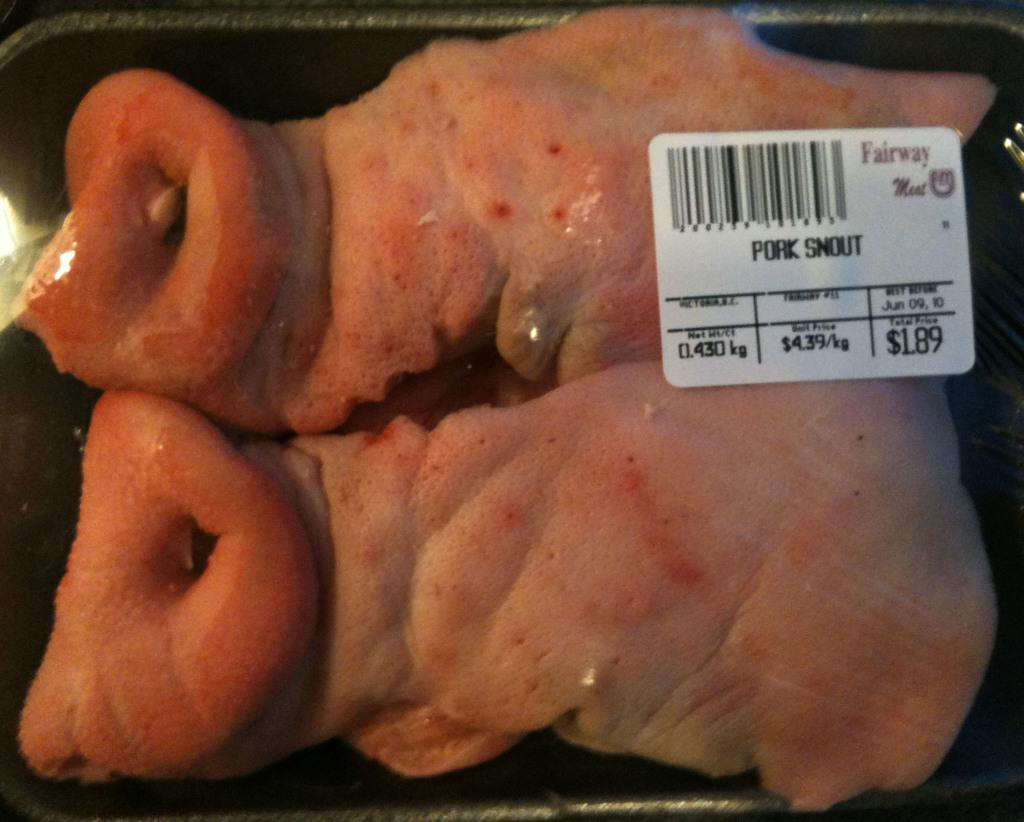What type of food is in the box in the image? There is meat in a box in the image. Is there any information about the cost of the meat in the image? Yes, there is a price tag in the image. What activity is the hose involved in within the image? There is no hose present in the image. 